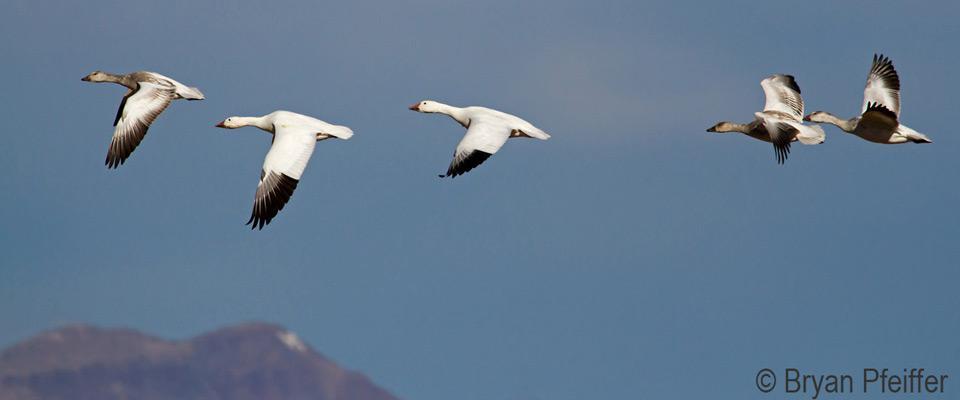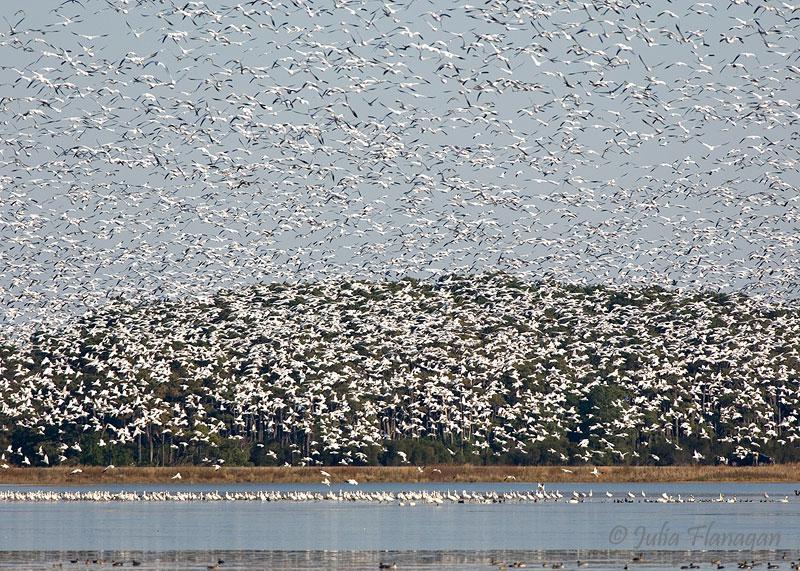The first image is the image on the left, the second image is the image on the right. For the images shown, is this caption "An image contains no more than five fowl." true? Answer yes or no. Yes. 